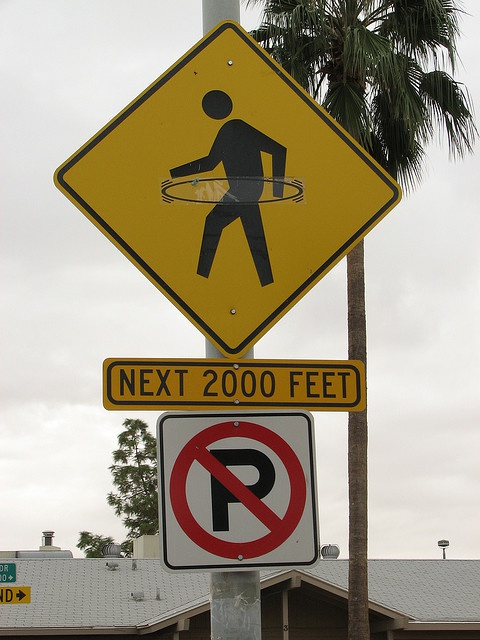Describe the objects in this image and their specific colors. I can see various objects in this image with different colors. 